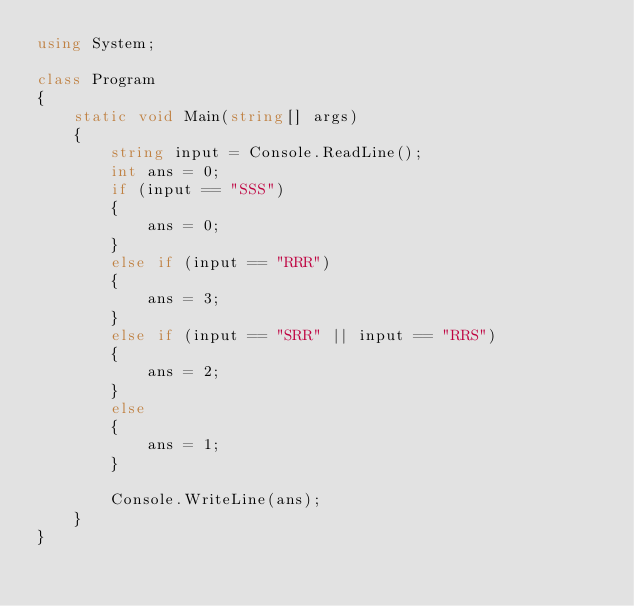Convert code to text. <code><loc_0><loc_0><loc_500><loc_500><_C#_>using System;

class Program
{
	static void Main(string[] args)
	{
		string input = Console.ReadLine();
		int ans = 0;
        if (input == "SSS")
        {
			ans = 0;
        }
        else if (input == "RRR")
        {
			ans = 3;
        }
		else if (input == "SRR" || input == "RRS")
        {
			ans = 2;
        }
        else
        {
            ans = 1;
        }

		Console.WriteLine(ans);
	}
}</code> 